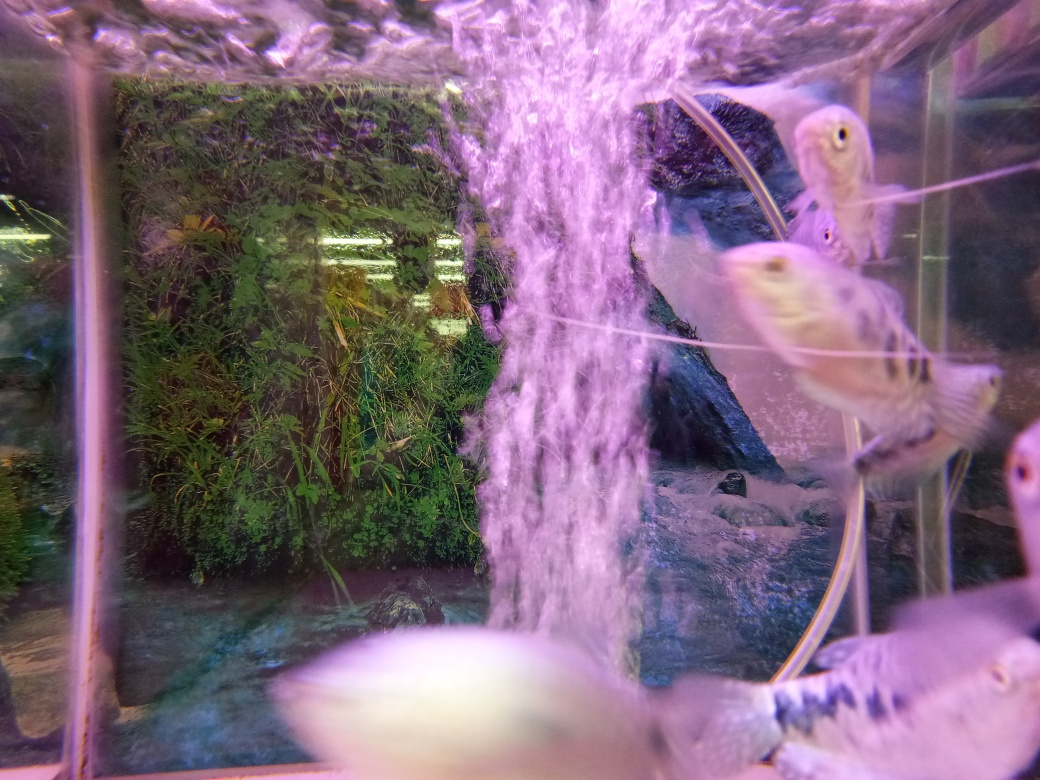What species of fish can we see in the image? The species of fish visible in the image appear to be angelfish, which are recognizable by their unique shape, with long fins, and their striped patterns. They are popular in aquariums due to their elegant appearance. 